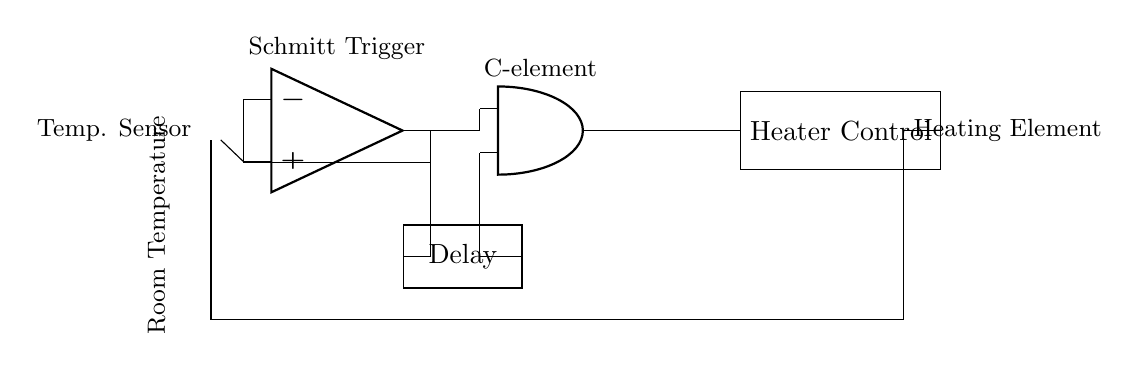What is the primary function of the thermistor? The thermistor is used as a temperature sensor that detects the room temperature. It is essential for monitoring the environmental variable that will be controlled by the heating system.
Answer: Temperature sensor What is the role of the Schmitt Trigger in this circuit? The Schmitt Trigger converts the analog temperature reading from the thermistor into a digital signal that can be processed by the downstream components. Its hysteresis feature ensures stable switching without flickering.
Answer: Signal conversion How many inputs does the C-element have? The C-element is an asynchronous logic gate that is designed to have two inputs that determine its output state based on the inputs' states.
Answer: Two What does the delay element accomplish in this circuit? The delay element introduces a necessary time lag that prevents rapid toggling of the C-element due to transient changes in the system, thus enhancing stability by ensuring the heating system does not turn on and off too quickly.
Answer: Time lag What component is directly controlling the heating element? The C-element’s output is connected to the heater control which directly manages the operation of the heating element based on the processed signals.
Answer: Heater control What type of feedback mechanism is present in the circuit? The circuit employs feedback from the heating element that informs the thermistor about the current state of the room temperature, allowing the system to adjust accordingly and maintain a desired temperature range.
Answer: Feedback 